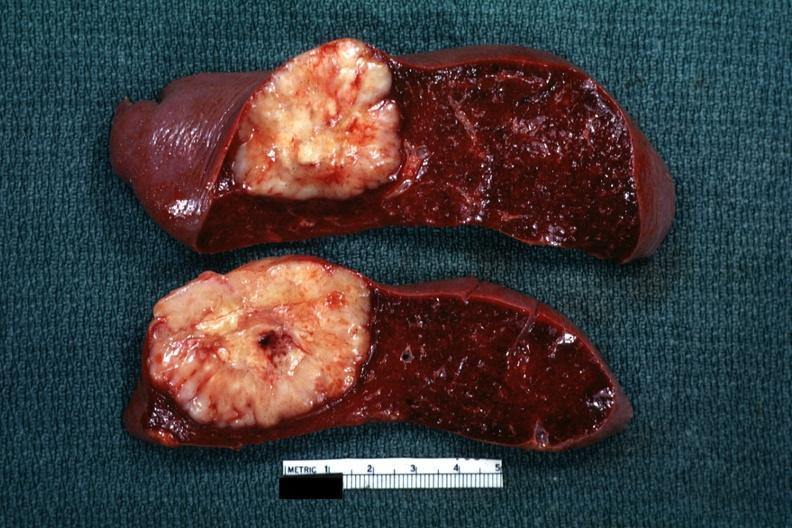what is present?
Answer the question using a single word or phrase. Spleen 